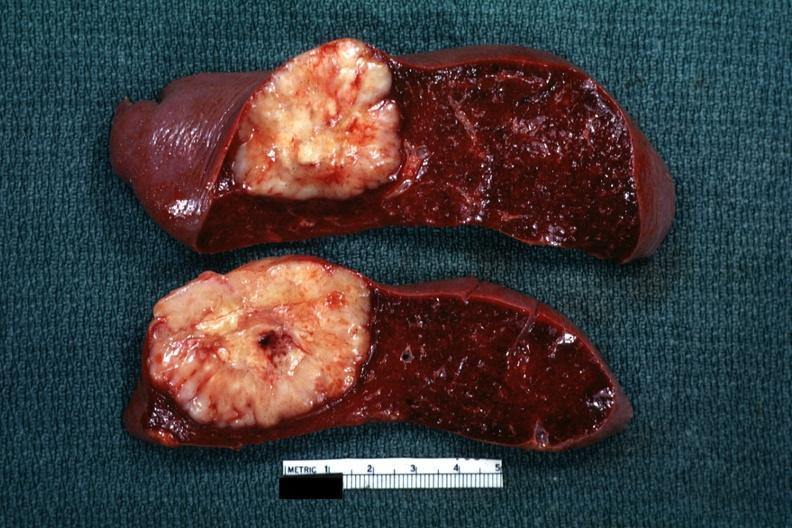what is present?
Answer the question using a single word or phrase. Spleen 